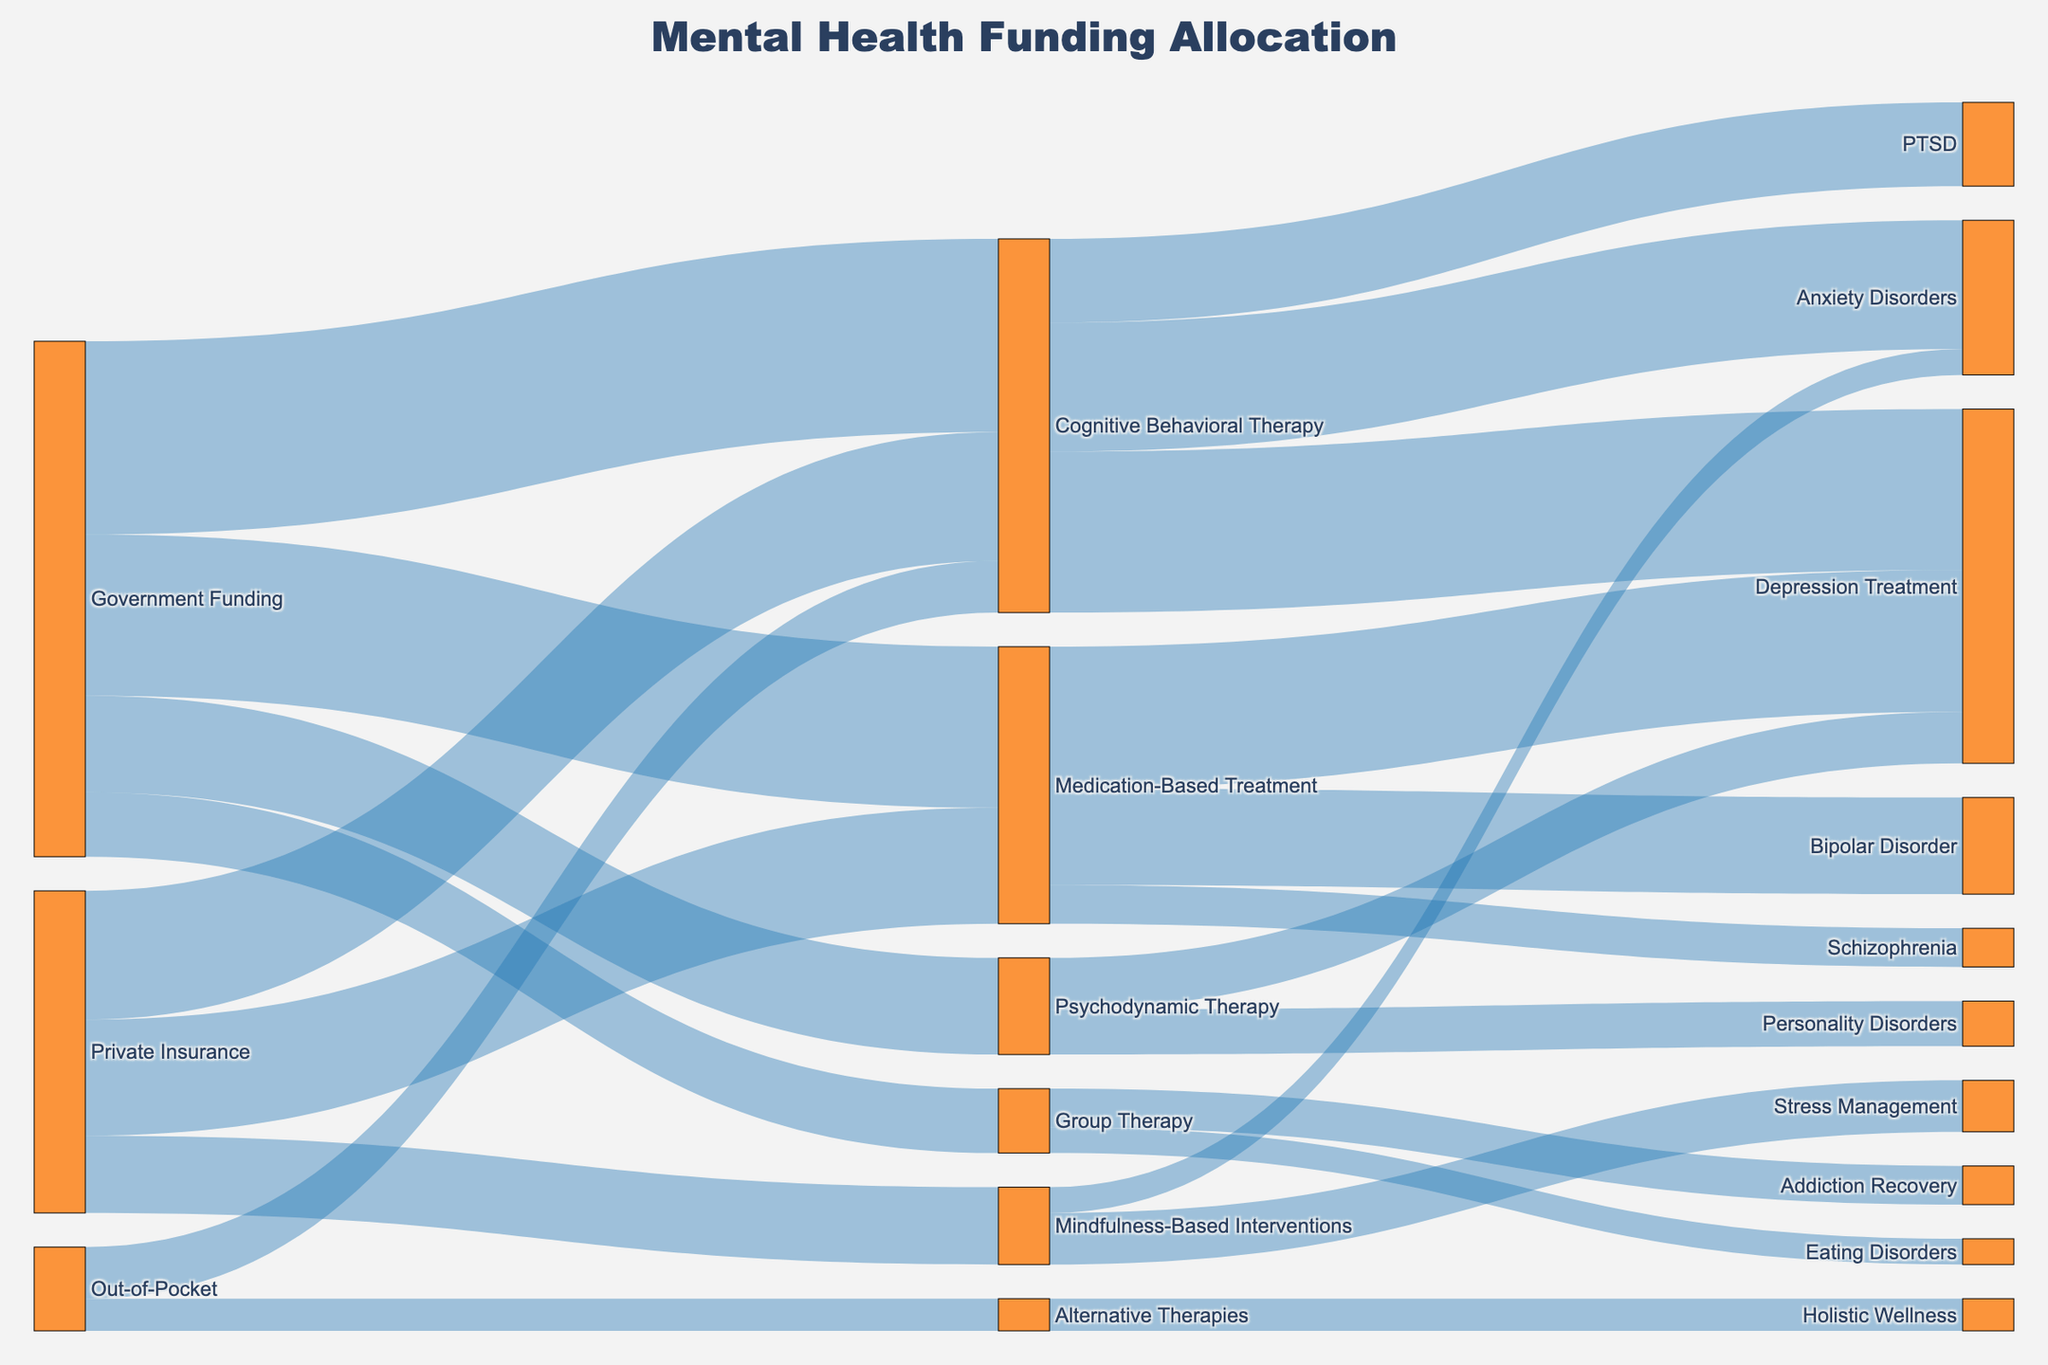What is the title of the Sankey diagram? The title of the diagram is usually displayed at the top center of the figure. In this case, the title is specified in the layout of the code provided.
Answer: Mental Health Funding Allocation How much funding does Cognitive Behavioral Therapy receive from Government Funding? To determine this, follow the link from "Government Funding" to "Cognitive Behavioral Therapy" and check the value associated, which is listed in the data table.
Answer: 30 What percentage of Government Funding goes to Medication-Based Treatment? First, find the total Government Funding by summing its values (30 + 25 + 15 + 10 = 80). Then, calculate the percentage for Medication-Based Treatment: (25 / 80) * 100%.
Answer: 31.25% Which treatment approach gets the most funding from Private Insurance? Check all the links originating from "Private Insurance" and compare their values to find the highest one.
Answer: Cognitive Behavioral Therapy How much funding in total goes to Depression Treatment? Sum all values leading to "Depression Treatment," which include: Cognitive Behavioral Therapy (25) and Medication-Based Treatment (22), and also Psychodynamic Therapy (8). The total is 25 + 22 + 8.
Answer: 55 Which treatment approach has the least funding from Government Funding? Compare the values leading from "Government Funding" and identify the smallest one.
Answer: Group Therapy What is the total funding allocated to Cognitive Behavioral Therapy from all sources? Sum all the values leading to "Cognitive Behavioral Therapy": Government Funding (30), Private Insurance (20), and Out-of-Pocket (8). Total is 30 + 20 + 8.
Answer: 58 Compare funding for Anxiety Disorders from different treatment approaches. Which approach receives the most funding? Follow links to "Anxiety Disorders" and compare their values: Cognitive Behavioral Therapy (20) and Mindfulness-Based Interventions (4), then identify the highest.
Answer: Cognitive Behavioral Therapy Which specific condition receives the highest funding from Medication-Based Treatment? Follow all links from "Medication-Based Treatment" and compare their values: Depression Treatment (22), Bipolar Disorder (15), and Schizophrenia (6). Identify the highest value.
Answer: Depression Treatment How does the funding for Alternative Therapies from Out-of-Pocket compare to Group Therapy from Government Funding? Identify and compare the values: Alternative Therapies from Out-of-Pocket is (5), Group Therapy from Government Funding is (10).
Answer: Group Therapy funding is higher 